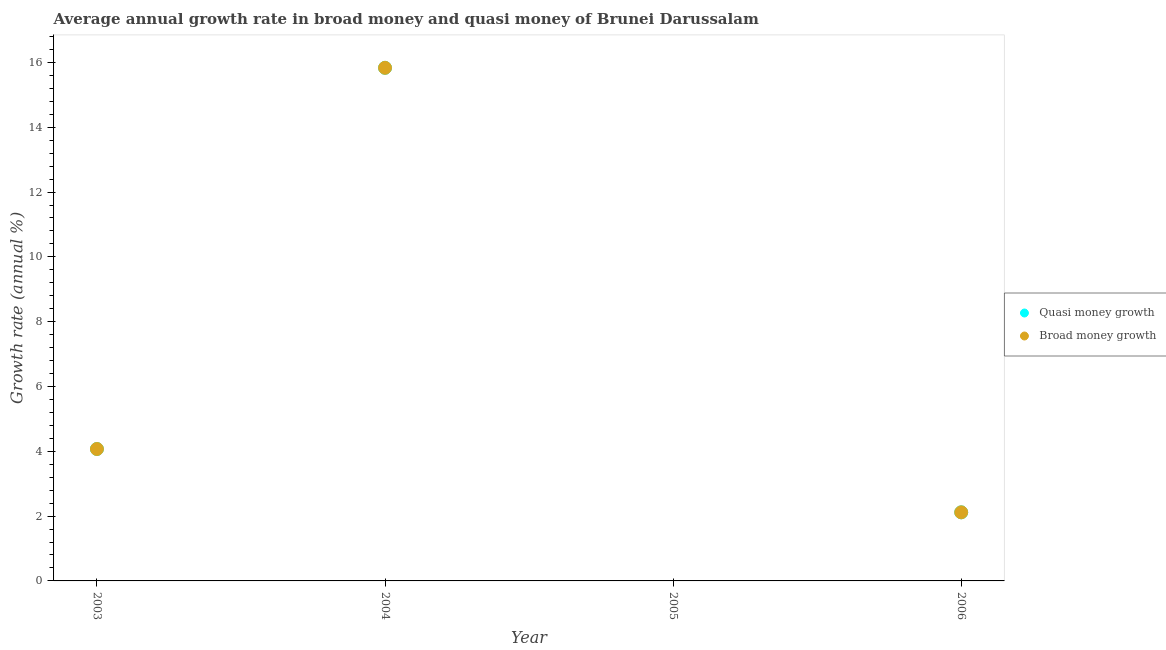How many different coloured dotlines are there?
Give a very brief answer. 2. What is the annual growth rate in broad money in 2004?
Ensure brevity in your answer.  15.83. Across all years, what is the maximum annual growth rate in broad money?
Offer a terse response. 15.83. Across all years, what is the minimum annual growth rate in broad money?
Give a very brief answer. 0. In which year was the annual growth rate in broad money maximum?
Keep it short and to the point. 2004. What is the total annual growth rate in broad money in the graph?
Offer a very short reply. 22.02. What is the difference between the annual growth rate in quasi money in 2003 and that in 2006?
Offer a very short reply. 1.95. What is the difference between the annual growth rate in broad money in 2006 and the annual growth rate in quasi money in 2005?
Keep it short and to the point. 2.12. What is the average annual growth rate in broad money per year?
Provide a succinct answer. 5.51. What is the ratio of the annual growth rate in broad money in 2003 to that in 2004?
Your response must be concise. 0.26. Is the difference between the annual growth rate in quasi money in 2003 and 2004 greater than the difference between the annual growth rate in broad money in 2003 and 2004?
Give a very brief answer. No. What is the difference between the highest and the second highest annual growth rate in broad money?
Offer a terse response. 11.76. What is the difference between the highest and the lowest annual growth rate in broad money?
Offer a terse response. 15.83. In how many years, is the annual growth rate in broad money greater than the average annual growth rate in broad money taken over all years?
Ensure brevity in your answer.  1. Is the sum of the annual growth rate in broad money in 2003 and 2006 greater than the maximum annual growth rate in quasi money across all years?
Your response must be concise. No. How many dotlines are there?
Offer a terse response. 2. How many years are there in the graph?
Provide a short and direct response. 4. Are the values on the major ticks of Y-axis written in scientific E-notation?
Your answer should be compact. No. Does the graph contain any zero values?
Give a very brief answer. Yes. Does the graph contain grids?
Provide a short and direct response. No. How many legend labels are there?
Give a very brief answer. 2. What is the title of the graph?
Provide a succinct answer. Average annual growth rate in broad money and quasi money of Brunei Darussalam. Does "Non-residents" appear as one of the legend labels in the graph?
Keep it short and to the point. No. What is the label or title of the X-axis?
Give a very brief answer. Year. What is the label or title of the Y-axis?
Make the answer very short. Growth rate (annual %). What is the Growth rate (annual %) in Quasi money growth in 2003?
Make the answer very short. 4.07. What is the Growth rate (annual %) of Broad money growth in 2003?
Provide a short and direct response. 4.07. What is the Growth rate (annual %) of Quasi money growth in 2004?
Your answer should be compact. 15.83. What is the Growth rate (annual %) in Broad money growth in 2004?
Ensure brevity in your answer.  15.83. What is the Growth rate (annual %) in Quasi money growth in 2006?
Your answer should be very brief. 2.12. What is the Growth rate (annual %) of Broad money growth in 2006?
Ensure brevity in your answer.  2.12. Across all years, what is the maximum Growth rate (annual %) in Quasi money growth?
Your answer should be compact. 15.83. Across all years, what is the maximum Growth rate (annual %) in Broad money growth?
Your answer should be very brief. 15.83. Across all years, what is the minimum Growth rate (annual %) in Broad money growth?
Offer a terse response. 0. What is the total Growth rate (annual %) of Quasi money growth in the graph?
Your response must be concise. 22.02. What is the total Growth rate (annual %) of Broad money growth in the graph?
Ensure brevity in your answer.  22.02. What is the difference between the Growth rate (annual %) in Quasi money growth in 2003 and that in 2004?
Your answer should be compact. -11.76. What is the difference between the Growth rate (annual %) of Broad money growth in 2003 and that in 2004?
Give a very brief answer. -11.76. What is the difference between the Growth rate (annual %) of Quasi money growth in 2003 and that in 2006?
Your response must be concise. 1.95. What is the difference between the Growth rate (annual %) of Broad money growth in 2003 and that in 2006?
Your answer should be compact. 1.95. What is the difference between the Growth rate (annual %) of Quasi money growth in 2004 and that in 2006?
Give a very brief answer. 13.72. What is the difference between the Growth rate (annual %) of Broad money growth in 2004 and that in 2006?
Give a very brief answer. 13.72. What is the difference between the Growth rate (annual %) of Quasi money growth in 2003 and the Growth rate (annual %) of Broad money growth in 2004?
Your answer should be very brief. -11.76. What is the difference between the Growth rate (annual %) in Quasi money growth in 2003 and the Growth rate (annual %) in Broad money growth in 2006?
Ensure brevity in your answer.  1.95. What is the difference between the Growth rate (annual %) of Quasi money growth in 2004 and the Growth rate (annual %) of Broad money growth in 2006?
Keep it short and to the point. 13.72. What is the average Growth rate (annual %) in Quasi money growth per year?
Your answer should be compact. 5.51. What is the average Growth rate (annual %) of Broad money growth per year?
Make the answer very short. 5.51. In the year 2003, what is the difference between the Growth rate (annual %) of Quasi money growth and Growth rate (annual %) of Broad money growth?
Ensure brevity in your answer.  0. In the year 2004, what is the difference between the Growth rate (annual %) of Quasi money growth and Growth rate (annual %) of Broad money growth?
Your answer should be very brief. 0. What is the ratio of the Growth rate (annual %) in Quasi money growth in 2003 to that in 2004?
Give a very brief answer. 0.26. What is the ratio of the Growth rate (annual %) in Broad money growth in 2003 to that in 2004?
Make the answer very short. 0.26. What is the ratio of the Growth rate (annual %) in Quasi money growth in 2003 to that in 2006?
Keep it short and to the point. 1.92. What is the ratio of the Growth rate (annual %) in Broad money growth in 2003 to that in 2006?
Offer a terse response. 1.92. What is the ratio of the Growth rate (annual %) in Quasi money growth in 2004 to that in 2006?
Your answer should be compact. 7.48. What is the ratio of the Growth rate (annual %) of Broad money growth in 2004 to that in 2006?
Keep it short and to the point. 7.48. What is the difference between the highest and the second highest Growth rate (annual %) in Quasi money growth?
Keep it short and to the point. 11.76. What is the difference between the highest and the second highest Growth rate (annual %) in Broad money growth?
Your response must be concise. 11.76. What is the difference between the highest and the lowest Growth rate (annual %) of Quasi money growth?
Keep it short and to the point. 15.83. What is the difference between the highest and the lowest Growth rate (annual %) of Broad money growth?
Your answer should be very brief. 15.83. 